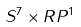Convert formula to latex. <formula><loc_0><loc_0><loc_500><loc_500>S ^ { 7 } \times { R } P ^ { 1 }</formula> 